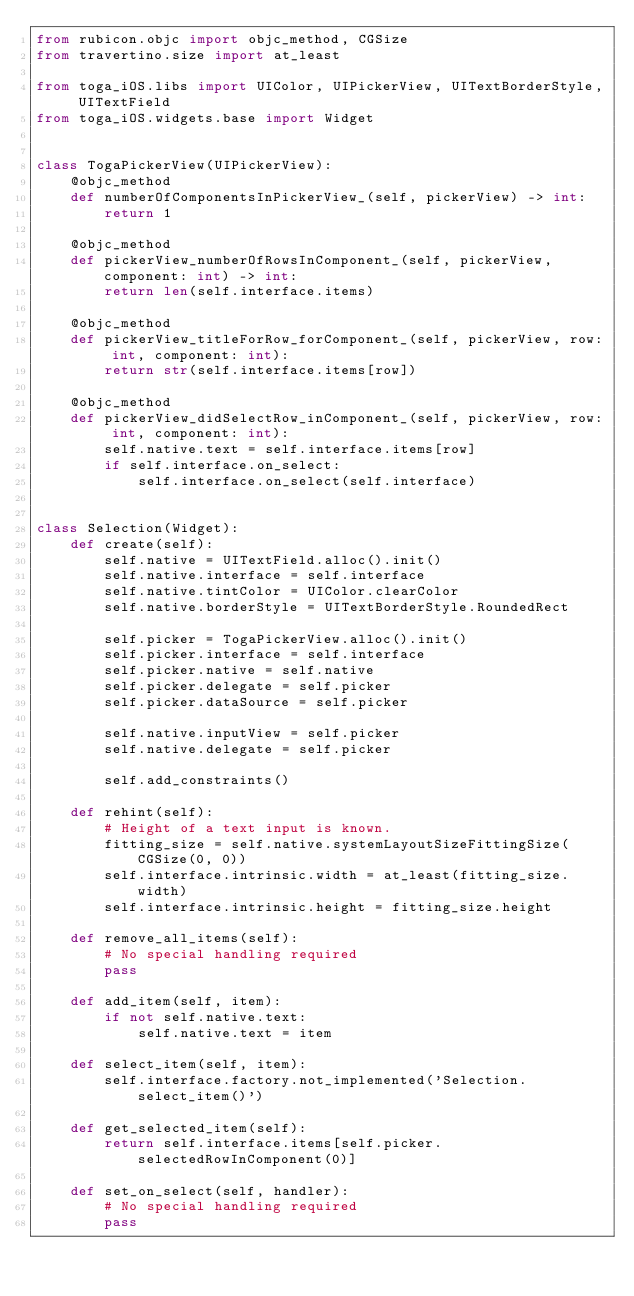<code> <loc_0><loc_0><loc_500><loc_500><_Python_>from rubicon.objc import objc_method, CGSize
from travertino.size import at_least

from toga_iOS.libs import UIColor, UIPickerView, UITextBorderStyle, UITextField
from toga_iOS.widgets.base import Widget


class TogaPickerView(UIPickerView):
    @objc_method
    def numberOfComponentsInPickerView_(self, pickerView) -> int:
        return 1

    @objc_method
    def pickerView_numberOfRowsInComponent_(self, pickerView, component: int) -> int:
        return len(self.interface.items)

    @objc_method
    def pickerView_titleForRow_forComponent_(self, pickerView, row: int, component: int):
        return str(self.interface.items[row])

    @objc_method
    def pickerView_didSelectRow_inComponent_(self, pickerView, row: int, component: int):
        self.native.text = self.interface.items[row]
        if self.interface.on_select:
            self.interface.on_select(self.interface)


class Selection(Widget):
    def create(self):
        self.native = UITextField.alloc().init()
        self.native.interface = self.interface
        self.native.tintColor = UIColor.clearColor
        self.native.borderStyle = UITextBorderStyle.RoundedRect

        self.picker = TogaPickerView.alloc().init()
        self.picker.interface = self.interface
        self.picker.native = self.native
        self.picker.delegate = self.picker
        self.picker.dataSource = self.picker

        self.native.inputView = self.picker
        self.native.delegate = self.picker

        self.add_constraints()

    def rehint(self):
        # Height of a text input is known.
        fitting_size = self.native.systemLayoutSizeFittingSize(CGSize(0, 0))
        self.interface.intrinsic.width = at_least(fitting_size.width)
        self.interface.intrinsic.height = fitting_size.height

    def remove_all_items(self):
        # No special handling required
        pass

    def add_item(self, item):
        if not self.native.text:
            self.native.text = item

    def select_item(self, item):
        self.interface.factory.not_implemented('Selection.select_item()')

    def get_selected_item(self):
        return self.interface.items[self.picker.selectedRowInComponent(0)]

    def set_on_select(self, handler):
        # No special handling required
        pass
</code> 